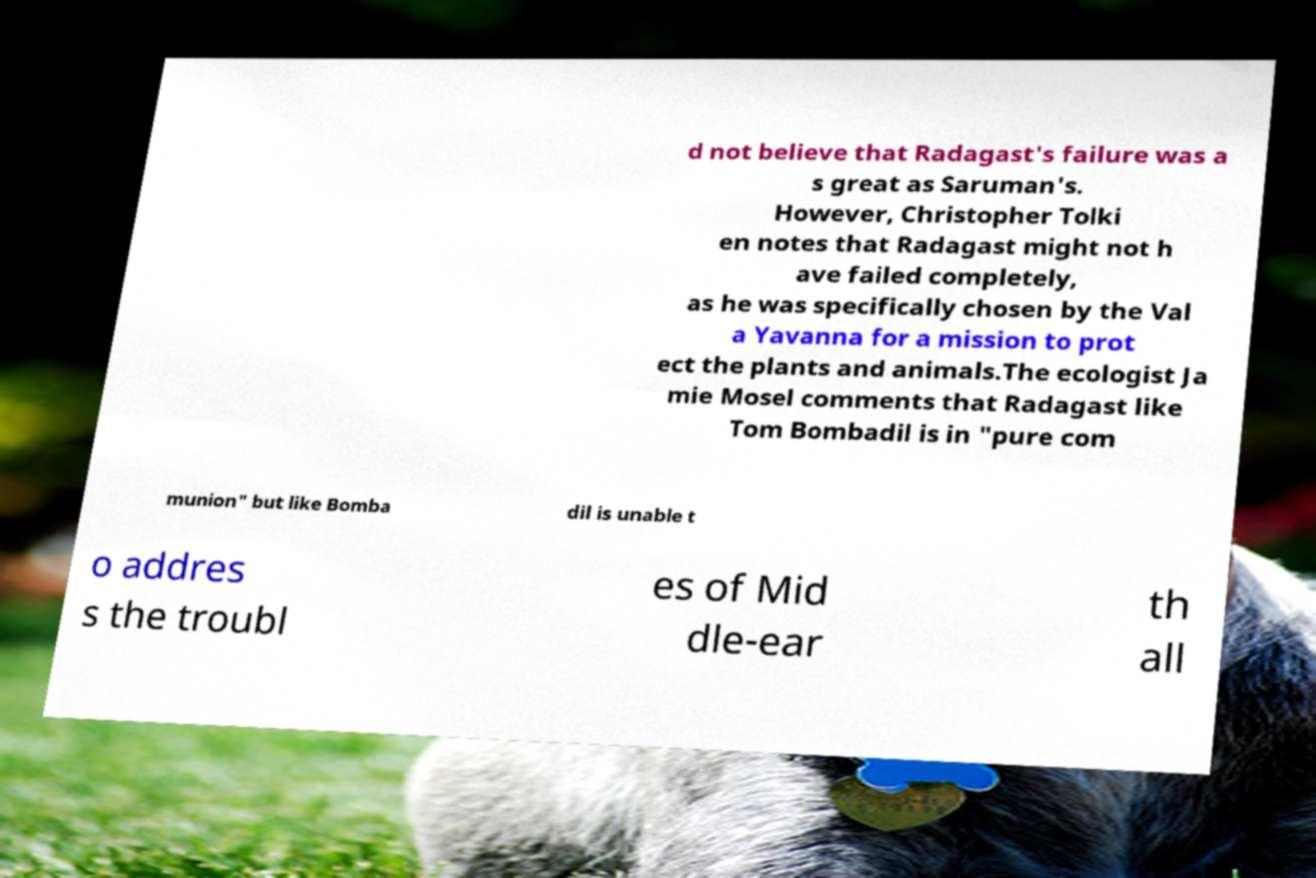I need the written content from this picture converted into text. Can you do that? d not believe that Radagast's failure was a s great as Saruman's. However, Christopher Tolki en notes that Radagast might not h ave failed completely, as he was specifically chosen by the Val a Yavanna for a mission to prot ect the plants and animals.The ecologist Ja mie Mosel comments that Radagast like Tom Bombadil is in "pure com munion" but like Bomba dil is unable t o addres s the troubl es of Mid dle-ear th all 